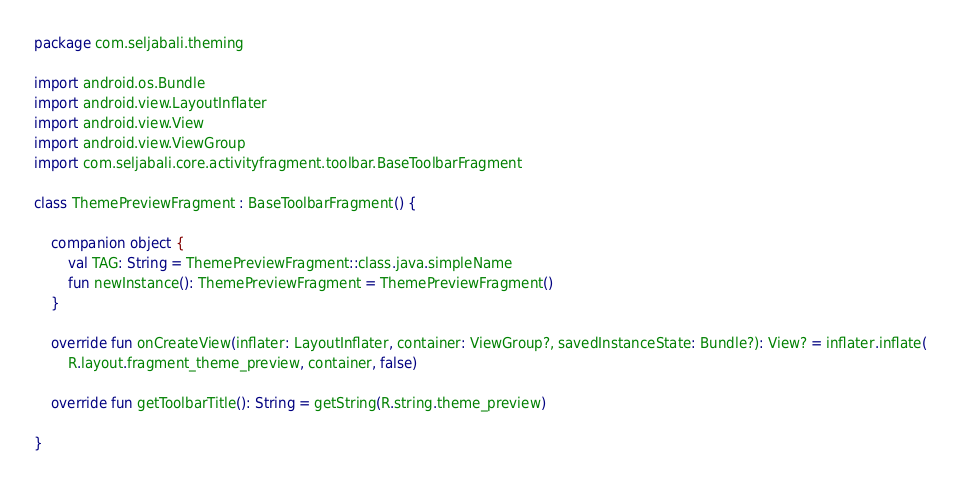Convert code to text. <code><loc_0><loc_0><loc_500><loc_500><_Kotlin_>package com.seljabali.theming

import android.os.Bundle
import android.view.LayoutInflater
import android.view.View
import android.view.ViewGroup
import com.seljabali.core.activityfragment.toolbar.BaseToolbarFragment

class ThemePreviewFragment : BaseToolbarFragment() {

    companion object {
        val TAG: String = ThemePreviewFragment::class.java.simpleName
        fun newInstance(): ThemePreviewFragment = ThemePreviewFragment()
    }

    override fun onCreateView(inflater: LayoutInflater, container: ViewGroup?, savedInstanceState: Bundle?): View? = inflater.inflate(
        R.layout.fragment_theme_preview, container, false)

    override fun getToolbarTitle(): String = getString(R.string.theme_preview)

}</code> 